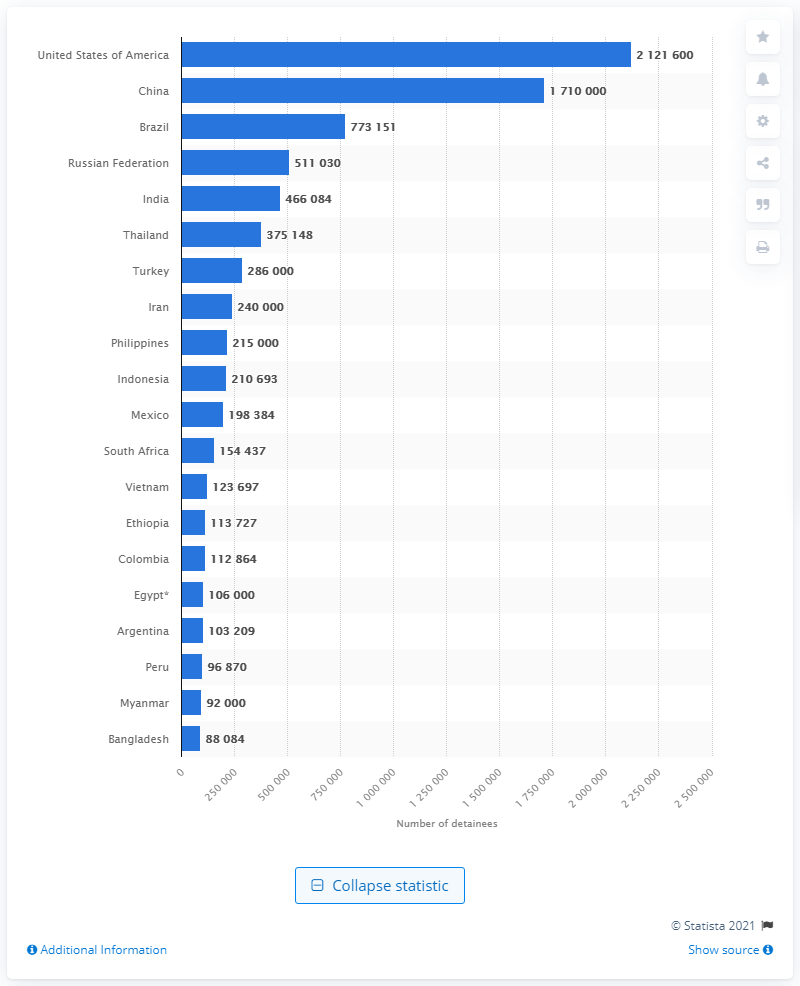Specify some key components in this picture. In June 2020, there were approximately 2,121,600 people incarcerated in the United States. 